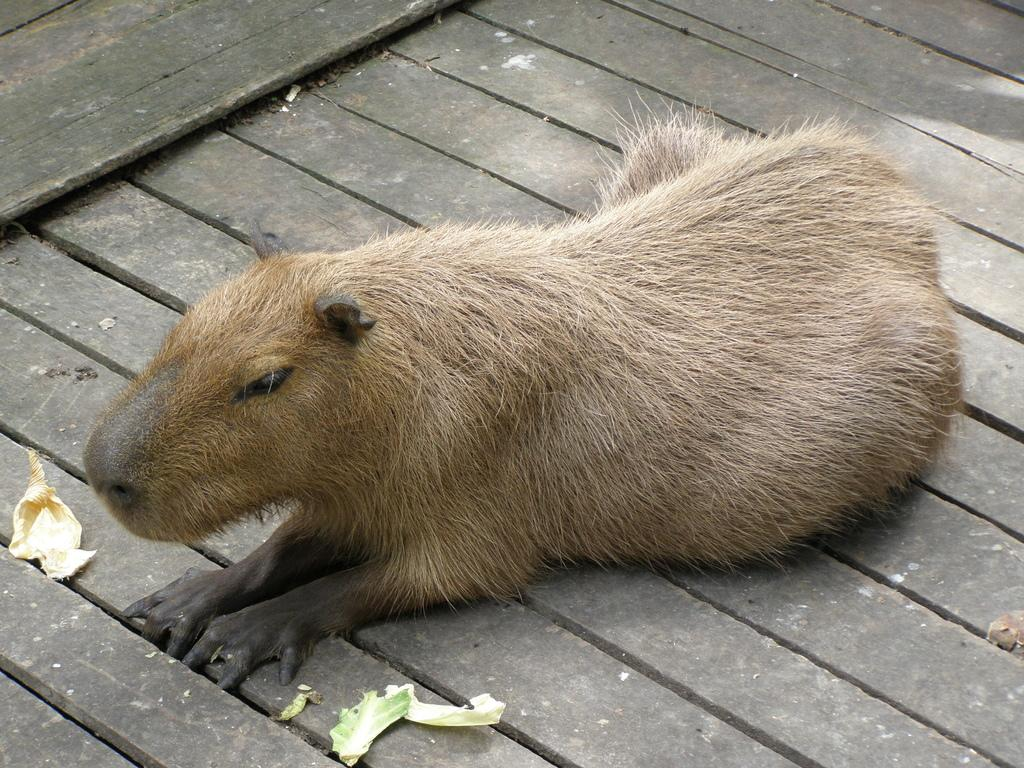What type of animal can be seen in the image? There is a brown-colored animal in the image. What else is visible in the image besides the animal? There are leaves visible in the image. Where is the bed located in the image? There is no bed present in the image. What type of star can be seen in the image? There is no star visible in the image. 